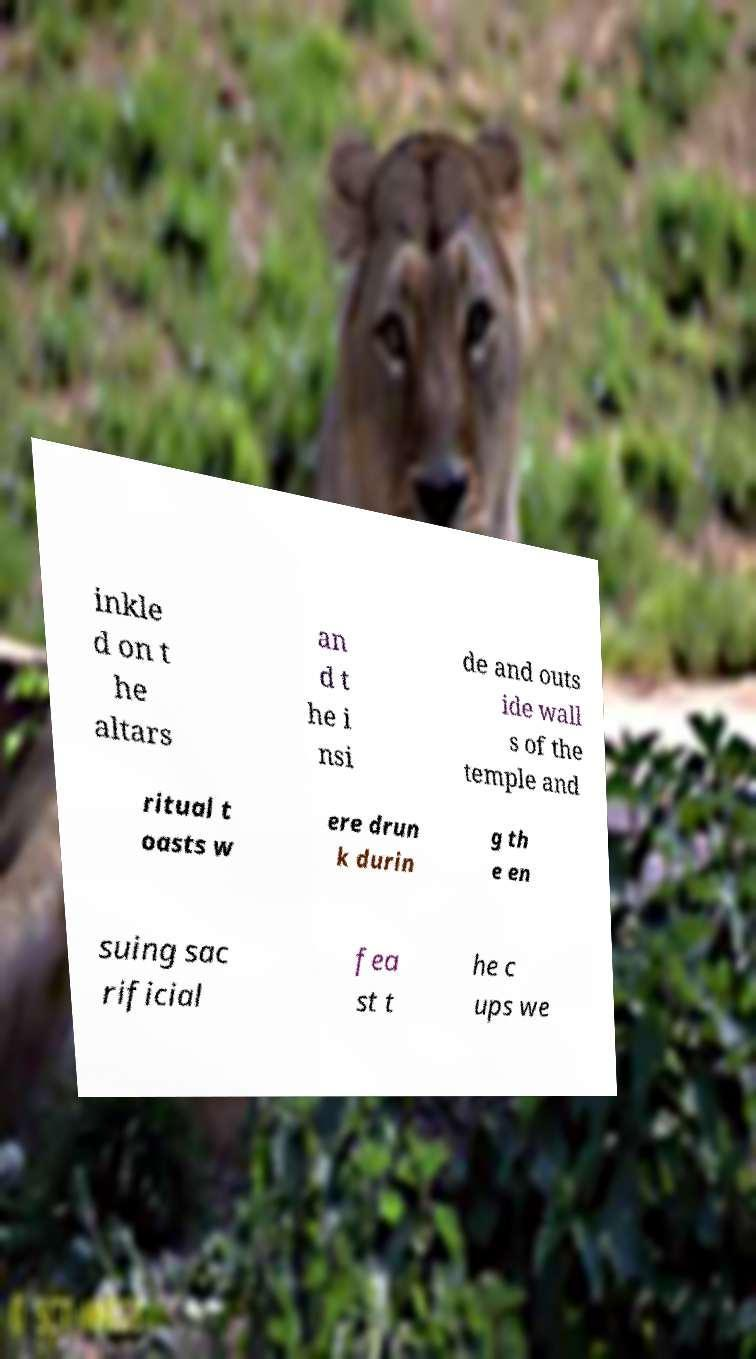Could you assist in decoding the text presented in this image and type it out clearly? inkle d on t he altars an d t he i nsi de and outs ide wall s of the temple and ritual t oasts w ere drun k durin g th e en suing sac rificial fea st t he c ups we 